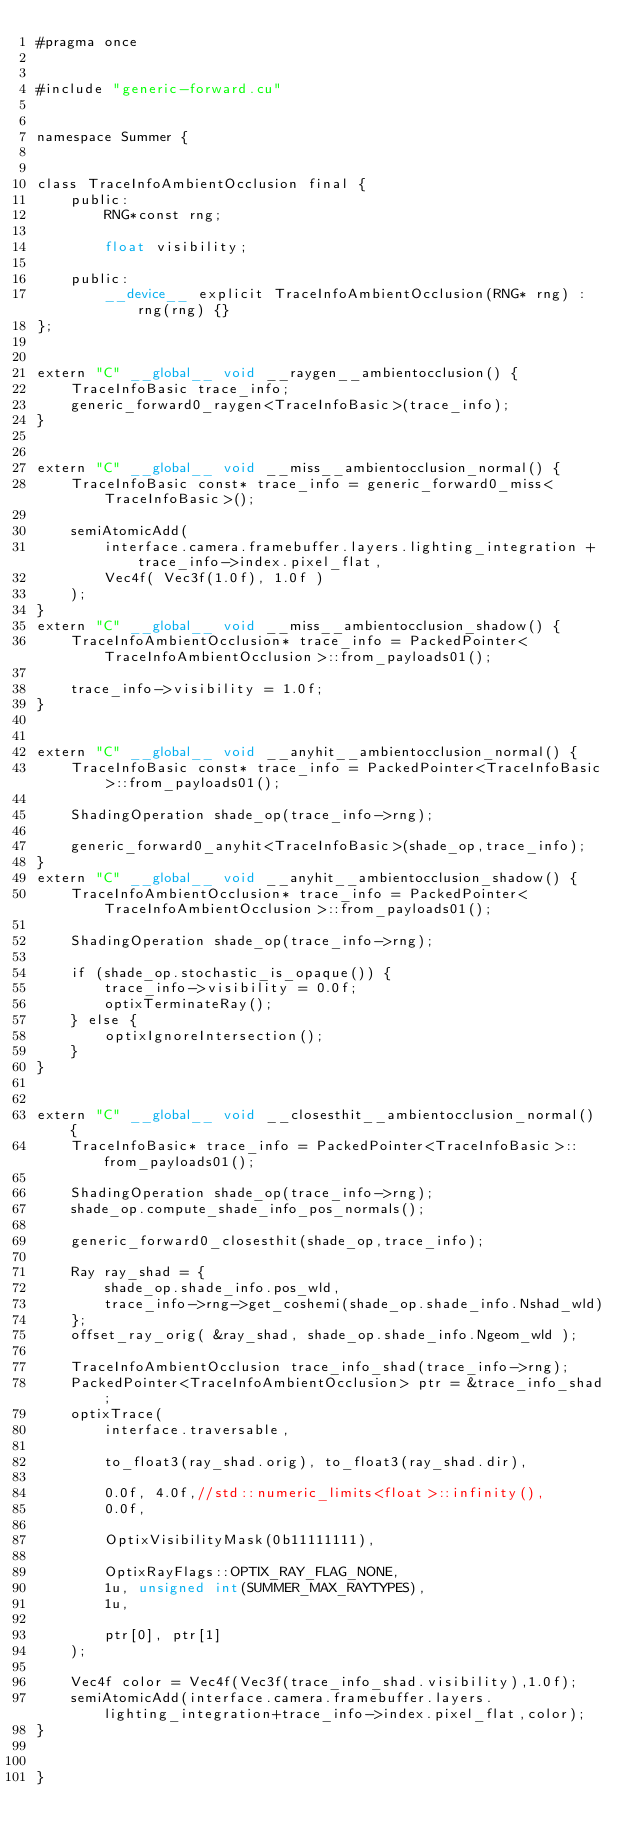<code> <loc_0><loc_0><loc_500><loc_500><_Cuda_>#pragma once


#include "generic-forward.cu"


namespace Summer {


class TraceInfoAmbientOcclusion final {
	public:
		RNG*const rng;

		float visibility;

	public:
		__device__ explicit TraceInfoAmbientOcclusion(RNG* rng) : rng(rng) {}
};


extern "C" __global__ void __raygen__ambientocclusion() {
	TraceInfoBasic trace_info;
	generic_forward0_raygen<TraceInfoBasic>(trace_info);
}


extern "C" __global__ void __miss__ambientocclusion_normal() {
	TraceInfoBasic const* trace_info = generic_forward0_miss<TraceInfoBasic>();

	semiAtomicAdd(
		interface.camera.framebuffer.layers.lighting_integration + trace_info->index.pixel_flat,
		Vec4f( Vec3f(1.0f), 1.0f )
	);
}
extern "C" __global__ void __miss__ambientocclusion_shadow() {
	TraceInfoAmbientOcclusion* trace_info = PackedPointer<TraceInfoAmbientOcclusion>::from_payloads01();

	trace_info->visibility = 1.0f;
}


extern "C" __global__ void __anyhit__ambientocclusion_normal() {
	TraceInfoBasic const* trace_info = PackedPointer<TraceInfoBasic>::from_payloads01();

	ShadingOperation shade_op(trace_info->rng);

	generic_forward0_anyhit<TraceInfoBasic>(shade_op,trace_info);
}
extern "C" __global__ void __anyhit__ambientocclusion_shadow() {
	TraceInfoAmbientOcclusion* trace_info = PackedPointer<TraceInfoAmbientOcclusion>::from_payloads01();

	ShadingOperation shade_op(trace_info->rng);

	if (shade_op.stochastic_is_opaque()) {
		trace_info->visibility = 0.0f;
		optixTerminateRay();
	} else {
		optixIgnoreIntersection();
	}
}


extern "C" __global__ void __closesthit__ambientocclusion_normal() {
	TraceInfoBasic* trace_info = PackedPointer<TraceInfoBasic>::from_payloads01();

	ShadingOperation shade_op(trace_info->rng);
	shade_op.compute_shade_info_pos_normals();

	generic_forward0_closesthit(shade_op,trace_info);

	Ray ray_shad = {
		shade_op.shade_info.pos_wld,
		trace_info->rng->get_coshemi(shade_op.shade_info.Nshad_wld)
	};
	offset_ray_orig( &ray_shad, shade_op.shade_info.Ngeom_wld );

	TraceInfoAmbientOcclusion trace_info_shad(trace_info->rng);
	PackedPointer<TraceInfoAmbientOcclusion> ptr = &trace_info_shad;
	optixTrace(
		interface.traversable,

		to_float3(ray_shad.orig), to_float3(ray_shad.dir),

		0.0f, 4.0f,//std::numeric_limits<float>::infinity(),
		0.0f,

		OptixVisibilityMask(0b11111111),

		OptixRayFlags::OPTIX_RAY_FLAG_NONE,
		1u, unsigned int(SUMMER_MAX_RAYTYPES),
		1u,

		ptr[0], ptr[1]
	);

	Vec4f color = Vec4f(Vec3f(trace_info_shad.visibility),1.0f);
	semiAtomicAdd(interface.camera.framebuffer.layers.lighting_integration+trace_info->index.pixel_flat,color);
}

  
}
</code> 